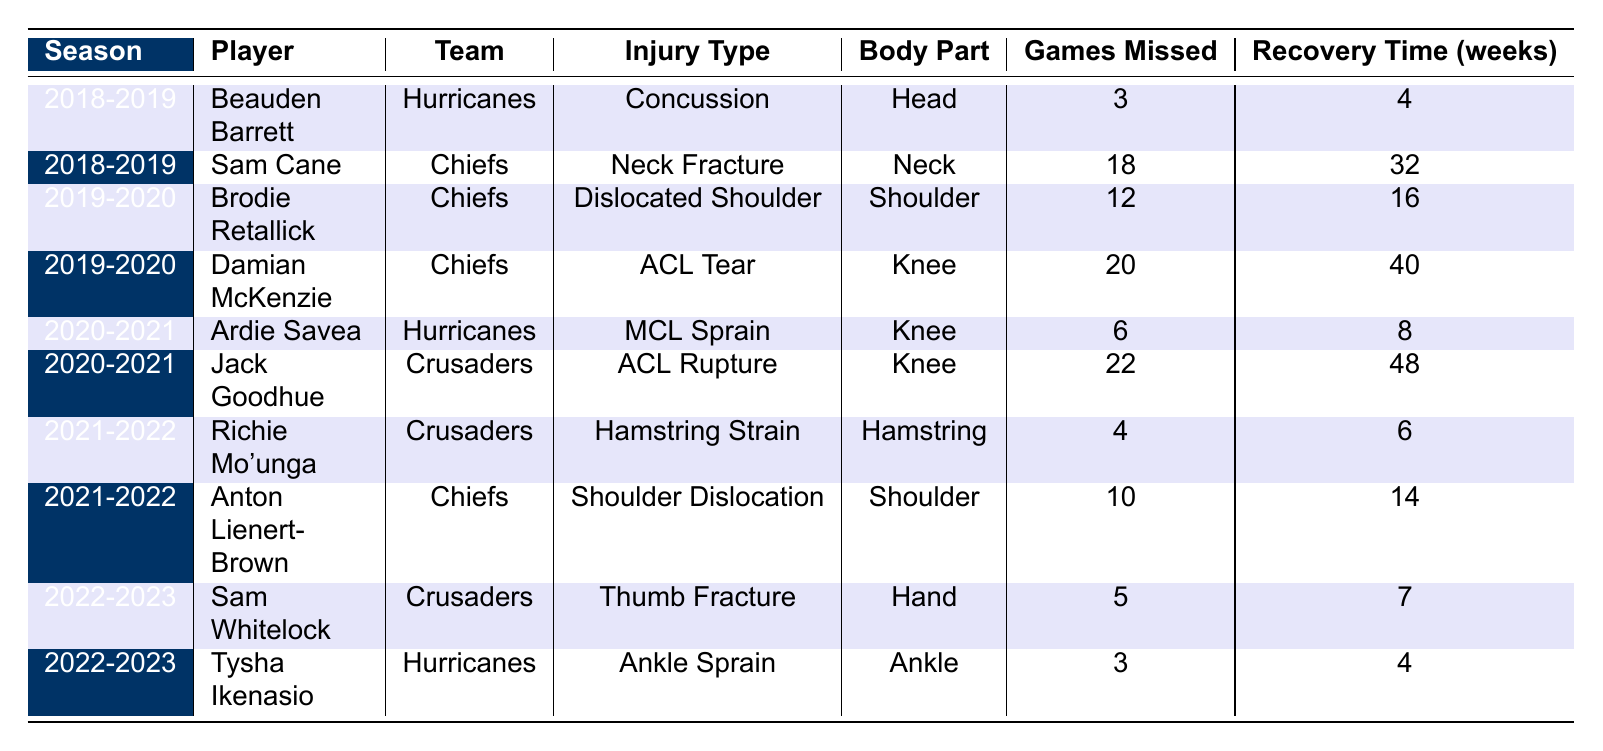What injury type did Tysha Ikenasio have? Looking at the row corresponding to Tysha Ikenasio in the table, the injury type listed is "Ankle Sprain."
Answer: Ankle Sprain Which player had the longest recovery time? By examining the 'Recovery Time (weeks)' column, Jack Goodhue has the longest recovery time of 48 weeks due to an ACL Rupture.
Answer: Jack Goodhue How many games did Damian McKenzie miss due to his injury? Referring to the table, Damian McKenzie missed 20 games as indicated in the 'Games Missed' column.
Answer: 20 What is the average recovery time for injuries in the 2020-2021 season? The recovery times for the 2020-2021 season are 8 weeks for Ardie Savea and 48 weeks for Jack Goodhue. The average is (8 + 48) / 2 = 28 weeks.
Answer: 28 weeks Did any player miss more than 15 games in a season? Yes, Sam Cane missed 18 games in the 2018-2019 season, which is more than 15 games.
Answer: Yes Which body part was most commonly injured based on the table? Looking at the 'Body Part' column, the knee appears three times (Damian McKenzie, Ardie Savea, and Jack Goodhue), which is more than any other body part.
Answer: Knee What is the total number of games missed by all players in the 2021-2022 season? The games missed in that season were 4 by Richie Mo'unga and 10 by Anton Lienert-Brown, totaling 4 + 10 = 14 games.
Answer: 14 games Which player had a concussion injury? The table shows that Beauden Barrett had a concussion in the 2018-2019 season.
Answer: Beauden Barrett What is the difference in games missed between the player with the most games missed and the player with the least? Jack Goodhue missed 22 games (most), while Tysha Ikenasio missed 3 games (least). The difference is 22 - 3 = 19 games.
Answer: 19 games Is there a season where no players missed fewer than 5 games? The 2021-2022 season has Richie Mo'unga and Anton Lienert-Brown with 4 and 10 games missed, respectively, meaning there was at least one player (Mo'unga) who missed fewer than 5 games.
Answer: No 